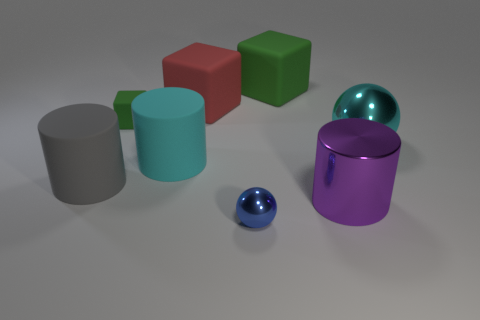What size is the cylinder that is the same color as the large metal sphere?
Keep it short and to the point. Large. There is a rubber thing that is on the left side of the green matte cube that is in front of the green thing that is to the right of the blue shiny object; what is its shape?
Offer a terse response. Cylinder. What is the small object behind the big purple metallic thing made of?
Keep it short and to the point. Rubber. There is a green matte cube on the right side of the cyan object in front of the cyan object on the right side of the small blue thing; how big is it?
Give a very brief answer. Large. Is the size of the purple object the same as the cyan object on the left side of the big cyan shiny thing?
Offer a very short reply. Yes. What color is the ball left of the big purple metallic cylinder?
Make the answer very short. Blue. There is a object that is the same color as the large sphere; what shape is it?
Offer a terse response. Cylinder. The green object that is on the right side of the big red object has what shape?
Your answer should be very brief. Cube. How many yellow objects are large rubber blocks or large objects?
Offer a very short reply. 0. Are the big gray cylinder and the big purple cylinder made of the same material?
Offer a very short reply. No. 